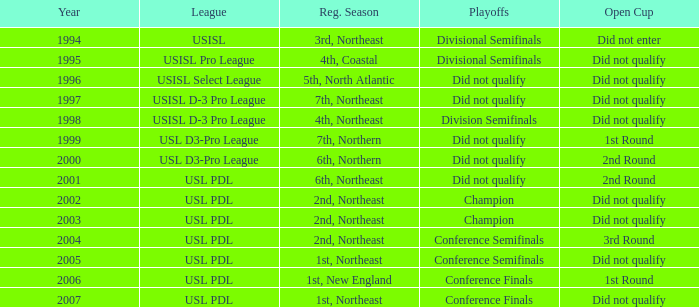Identify the 2001 regular season. 6th, Northeast. 